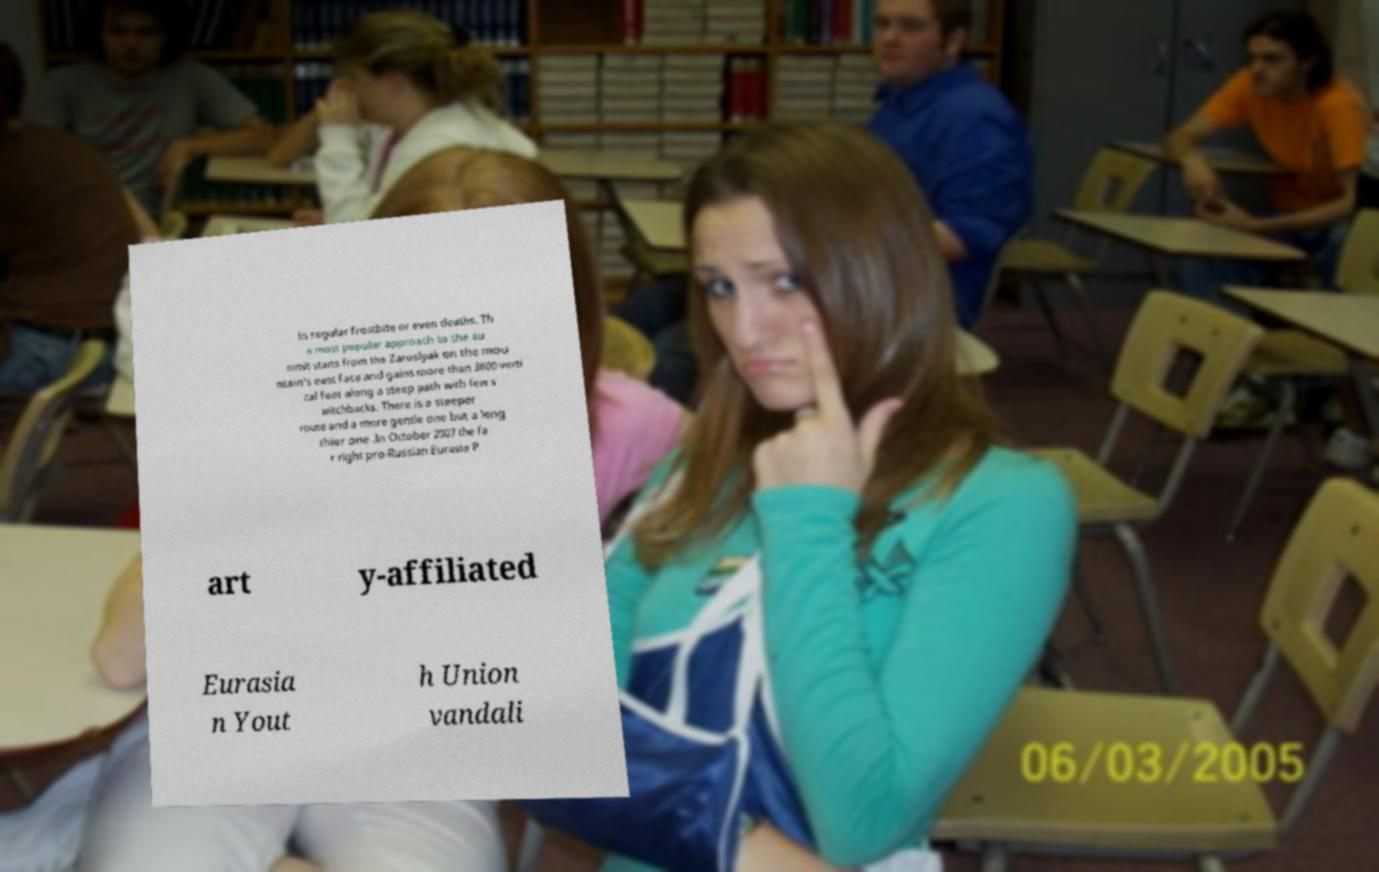Can you read and provide the text displayed in the image?This photo seems to have some interesting text. Can you extract and type it out for me? in regular frostbite or even deaths. Th e most popular approach to the su mmit starts from the Zaroslyak on the mou ntain's east face and gains more than 3600 verti cal feet along a steep path with few s witchbacks. There is a steeper route and a more gentle one but a leng thier one .In October 2007 the fa r right pro-Russian Eurasia P art y-affiliated Eurasia n Yout h Union vandali 